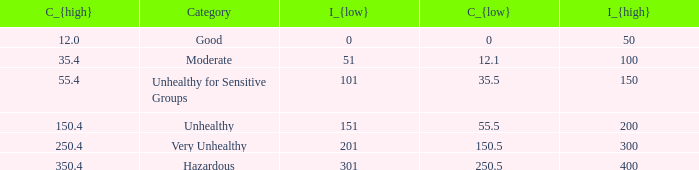What's the i_{high} value when C_{low} is 250.5? 400.0. 